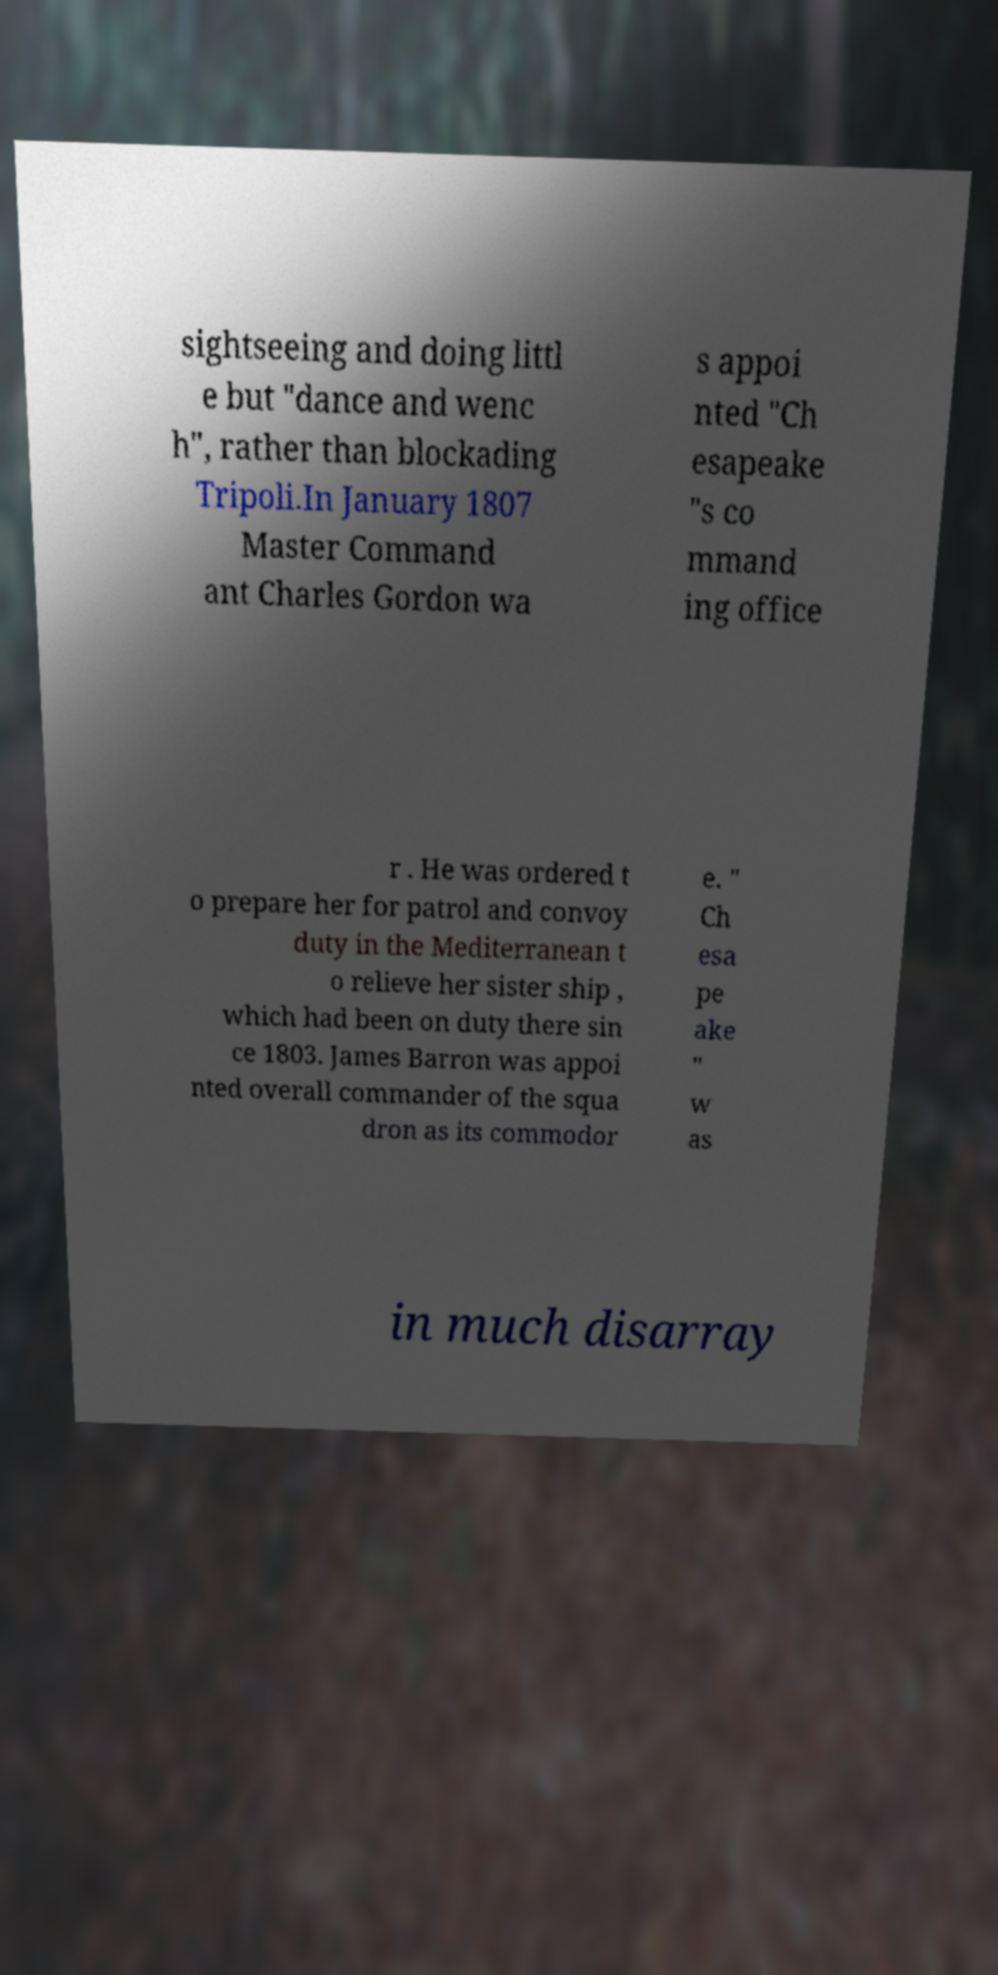There's text embedded in this image that I need extracted. Can you transcribe it verbatim? sightseeing and doing littl e but "dance and wenc h", rather than blockading Tripoli.In January 1807 Master Command ant Charles Gordon wa s appoi nted "Ch esapeake "s co mmand ing office r . He was ordered t o prepare her for patrol and convoy duty in the Mediterranean t o relieve her sister ship , which had been on duty there sin ce 1803. James Barron was appoi nted overall commander of the squa dron as its commodor e. " Ch esa pe ake " w as in much disarray 